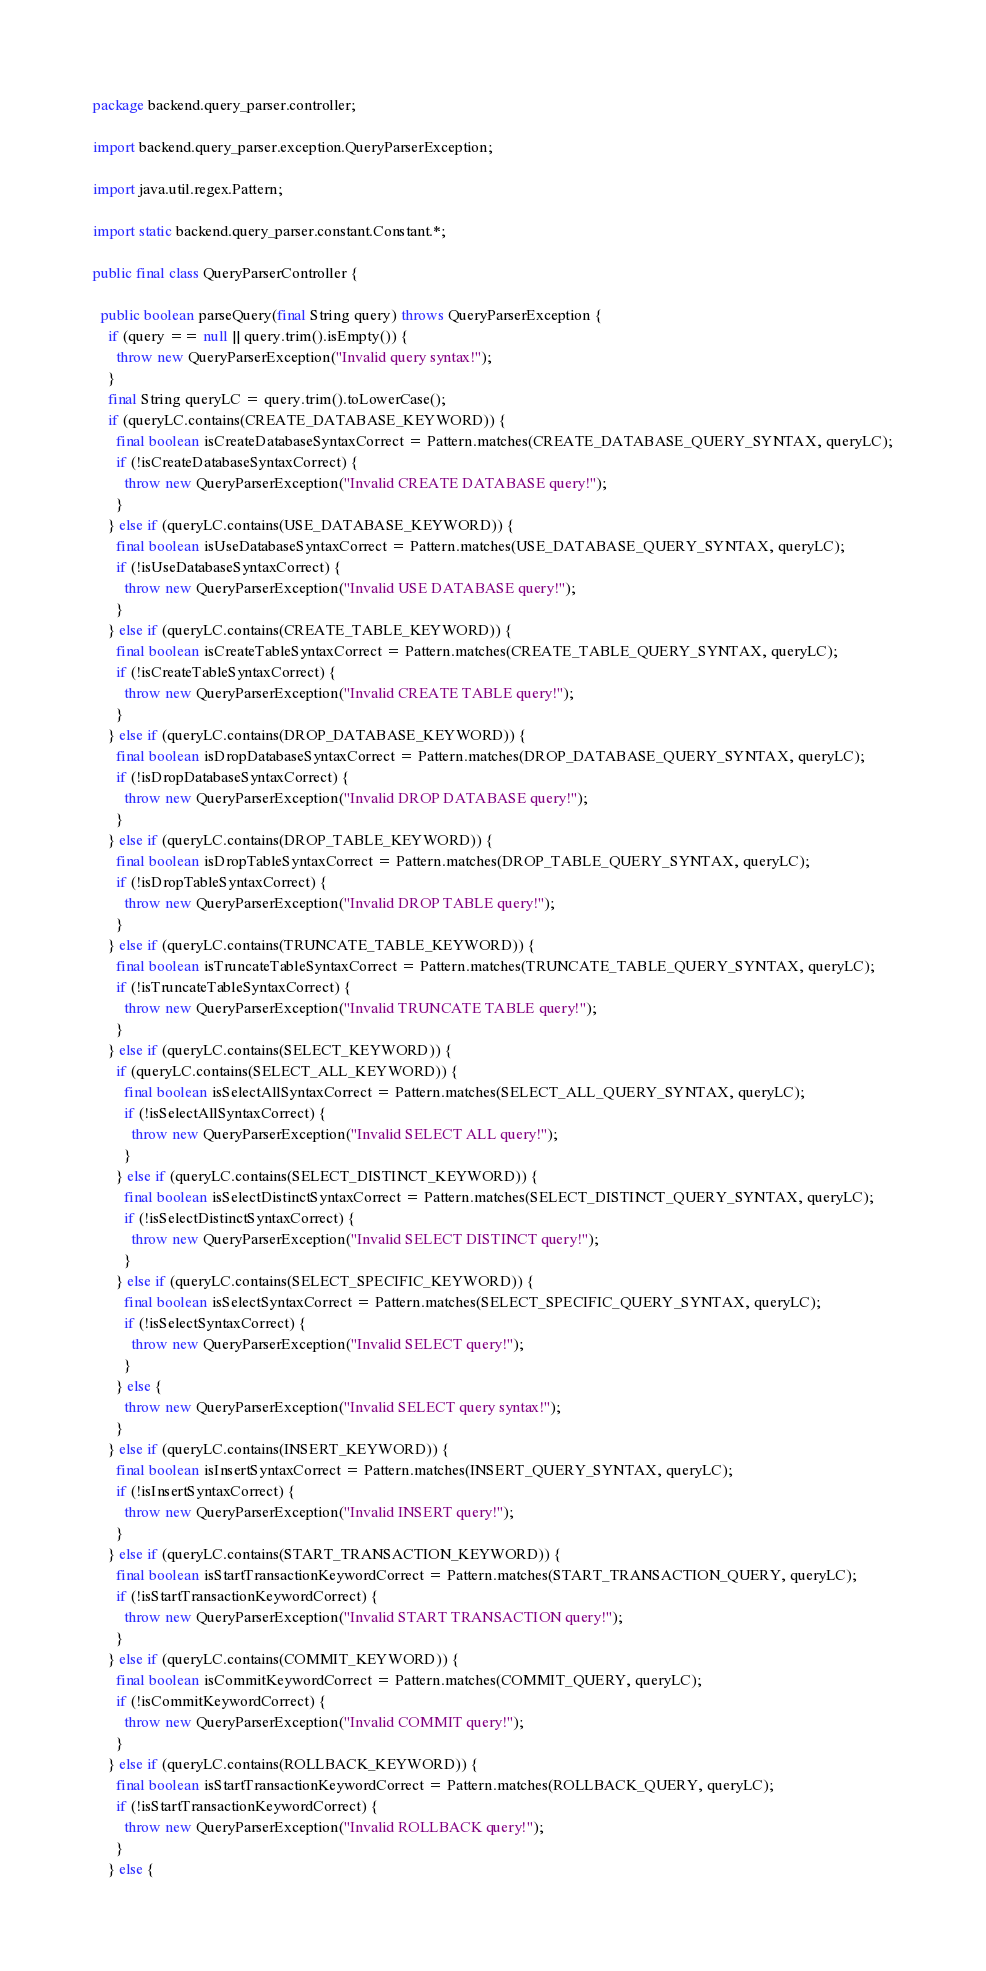<code> <loc_0><loc_0><loc_500><loc_500><_Java_>package backend.query_parser.controller;

import backend.query_parser.exception.QueryParserException;

import java.util.regex.Pattern;

import static backend.query_parser.constant.Constant.*;

public final class QueryParserController {

  public boolean parseQuery(final String query) throws QueryParserException {
    if (query == null || query.trim().isEmpty()) {
      throw new QueryParserException("Invalid query syntax!");
    }
    final String queryLC = query.trim().toLowerCase();
    if (queryLC.contains(CREATE_DATABASE_KEYWORD)) {
      final boolean isCreateDatabaseSyntaxCorrect = Pattern.matches(CREATE_DATABASE_QUERY_SYNTAX, queryLC);
      if (!isCreateDatabaseSyntaxCorrect) {
        throw new QueryParserException("Invalid CREATE DATABASE query!");
      }
    } else if (queryLC.contains(USE_DATABASE_KEYWORD)) {
      final boolean isUseDatabaseSyntaxCorrect = Pattern.matches(USE_DATABASE_QUERY_SYNTAX, queryLC);
      if (!isUseDatabaseSyntaxCorrect) {
        throw new QueryParserException("Invalid USE DATABASE query!");
      }
    } else if (queryLC.contains(CREATE_TABLE_KEYWORD)) {
      final boolean isCreateTableSyntaxCorrect = Pattern.matches(CREATE_TABLE_QUERY_SYNTAX, queryLC);
      if (!isCreateTableSyntaxCorrect) {
        throw new QueryParserException("Invalid CREATE TABLE query!");
      }
    } else if (queryLC.contains(DROP_DATABASE_KEYWORD)) {
      final boolean isDropDatabaseSyntaxCorrect = Pattern.matches(DROP_DATABASE_QUERY_SYNTAX, queryLC);
      if (!isDropDatabaseSyntaxCorrect) {
        throw new QueryParserException("Invalid DROP DATABASE query!");
      }
    } else if (queryLC.contains(DROP_TABLE_KEYWORD)) {
      final boolean isDropTableSyntaxCorrect = Pattern.matches(DROP_TABLE_QUERY_SYNTAX, queryLC);
      if (!isDropTableSyntaxCorrect) {
        throw new QueryParserException("Invalid DROP TABLE query!");
      }
    } else if (queryLC.contains(TRUNCATE_TABLE_KEYWORD)) {
      final boolean isTruncateTableSyntaxCorrect = Pattern.matches(TRUNCATE_TABLE_QUERY_SYNTAX, queryLC);
      if (!isTruncateTableSyntaxCorrect) {
        throw new QueryParserException("Invalid TRUNCATE TABLE query!");
      }
    } else if (queryLC.contains(SELECT_KEYWORD)) {
      if (queryLC.contains(SELECT_ALL_KEYWORD)) {
        final boolean isSelectAllSyntaxCorrect = Pattern.matches(SELECT_ALL_QUERY_SYNTAX, queryLC);
        if (!isSelectAllSyntaxCorrect) {
          throw new QueryParserException("Invalid SELECT ALL query!");
        }
      } else if (queryLC.contains(SELECT_DISTINCT_KEYWORD)) {
        final boolean isSelectDistinctSyntaxCorrect = Pattern.matches(SELECT_DISTINCT_QUERY_SYNTAX, queryLC);
        if (!isSelectDistinctSyntaxCorrect) {
          throw new QueryParserException("Invalid SELECT DISTINCT query!");
        }
      } else if (queryLC.contains(SELECT_SPECIFIC_KEYWORD)) {
        final boolean isSelectSyntaxCorrect = Pattern.matches(SELECT_SPECIFIC_QUERY_SYNTAX, queryLC);
        if (!isSelectSyntaxCorrect) {
          throw new QueryParserException("Invalid SELECT query!");
        }
      } else {
        throw new QueryParserException("Invalid SELECT query syntax!");
      }
    } else if (queryLC.contains(INSERT_KEYWORD)) {
      final boolean isInsertSyntaxCorrect = Pattern.matches(INSERT_QUERY_SYNTAX, queryLC);
      if (!isInsertSyntaxCorrect) {
        throw new QueryParserException("Invalid INSERT query!");
      }
    } else if (queryLC.contains(START_TRANSACTION_KEYWORD)) {
      final boolean isStartTransactionKeywordCorrect = Pattern.matches(START_TRANSACTION_QUERY, queryLC);
      if (!isStartTransactionKeywordCorrect) {
        throw new QueryParserException("Invalid START TRANSACTION query!");
      }
    } else if (queryLC.contains(COMMIT_KEYWORD)) {
      final boolean isCommitKeywordCorrect = Pattern.matches(COMMIT_QUERY, queryLC);
      if (!isCommitKeywordCorrect) {
        throw new QueryParserException("Invalid COMMIT query!");
      }
    } else if (queryLC.contains(ROLLBACK_KEYWORD)) {
      final boolean isStartTransactionKeywordCorrect = Pattern.matches(ROLLBACK_QUERY, queryLC);
      if (!isStartTransactionKeywordCorrect) {
        throw new QueryParserException("Invalid ROLLBACK query!");
      }
    } else {</code> 